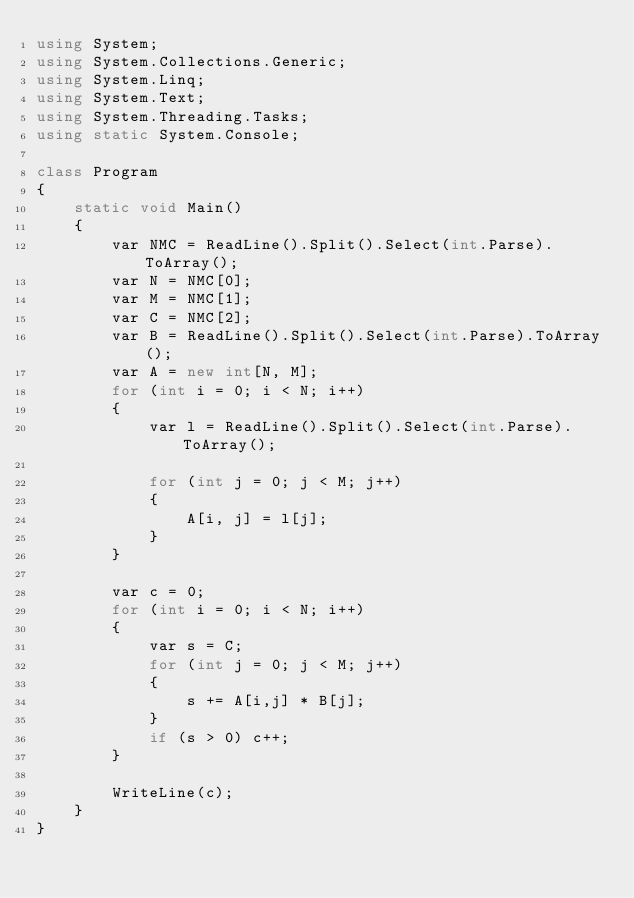<code> <loc_0><loc_0><loc_500><loc_500><_C#_>using System;
using System.Collections.Generic;
using System.Linq;
using System.Text;
using System.Threading.Tasks;
using static System.Console;

class Program
{
    static void Main()
    {
        var NMC = ReadLine().Split().Select(int.Parse).ToArray();
        var N = NMC[0];
        var M = NMC[1];
        var C = NMC[2];
        var B = ReadLine().Split().Select(int.Parse).ToArray();
        var A = new int[N, M];
        for (int i = 0; i < N; i++)
        {
            var l = ReadLine().Split().Select(int.Parse).ToArray();

            for (int j = 0; j < M; j++)
            {
                A[i, j] = l[j];
            }
        }

        var c = 0;
        for (int i = 0; i < N; i++)
        {
            var s = C;
            for (int j = 0; j < M; j++)
            {
                s += A[i,j] * B[j];
            }
            if (s > 0) c++;
        }

        WriteLine(c);
    }
}

</code> 